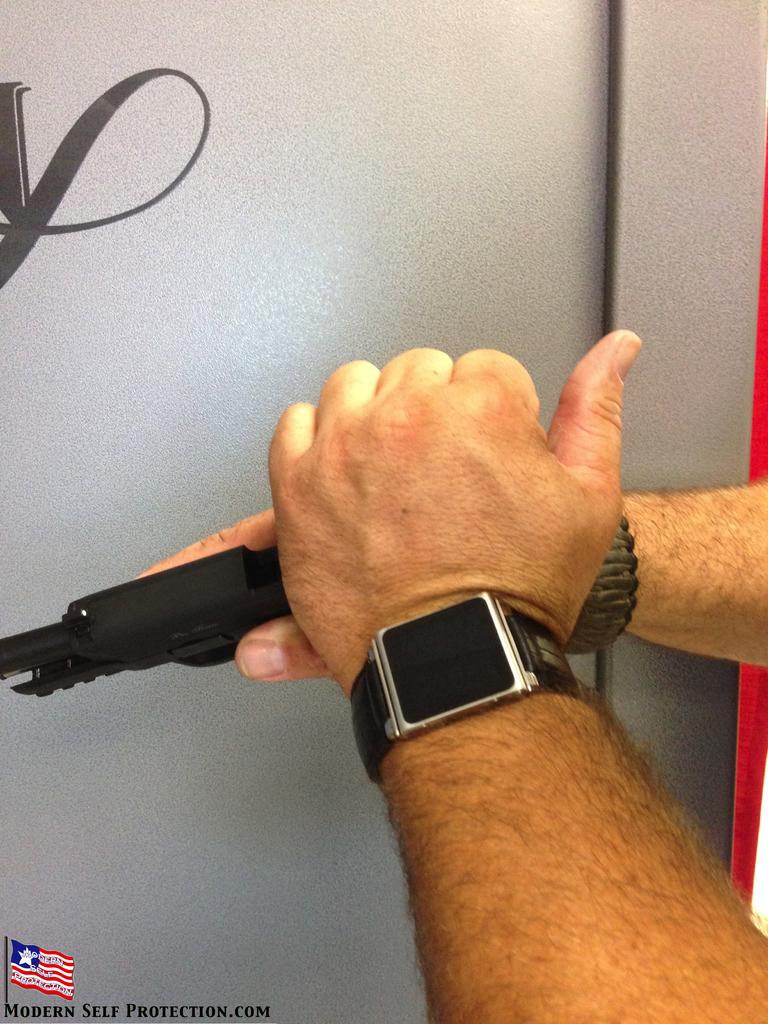Is this picture from modern self protection?
Give a very brief answer. Yes. 